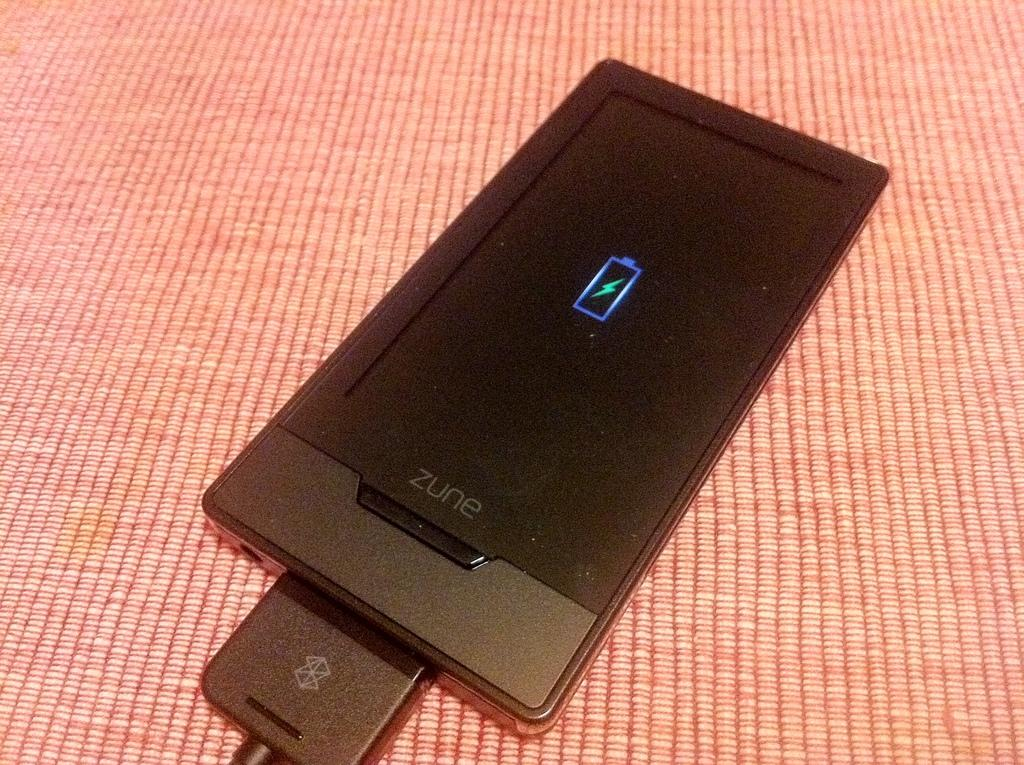<image>
Summarize the visual content of the image. A black Zune charging on a woven mat. 